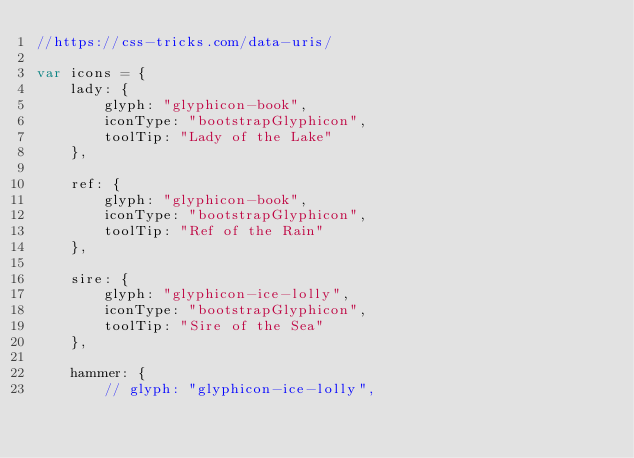Convert code to text. <code><loc_0><loc_0><loc_500><loc_500><_JavaScript_>//https://css-tricks.com/data-uris/

var icons = {
    lady: {
        glyph: "glyphicon-book",
        iconType: "bootstrapGlyphicon",
        toolTip: "Lady of the Lake"
    },

    ref: {
        glyph: "glyphicon-book",
        iconType: "bootstrapGlyphicon",
        toolTip: "Ref of the Rain"
    },

    sire: {
        glyph: "glyphicon-ice-lolly",
        iconType: "bootstrapGlyphicon",
        toolTip: "Sire of the Sea"
    },

    hammer: {
        // glyph: "glyphicon-ice-lolly",</code> 